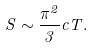<formula> <loc_0><loc_0><loc_500><loc_500>S \sim \frac { \pi ^ { 2 } } { 3 } c T .</formula> 